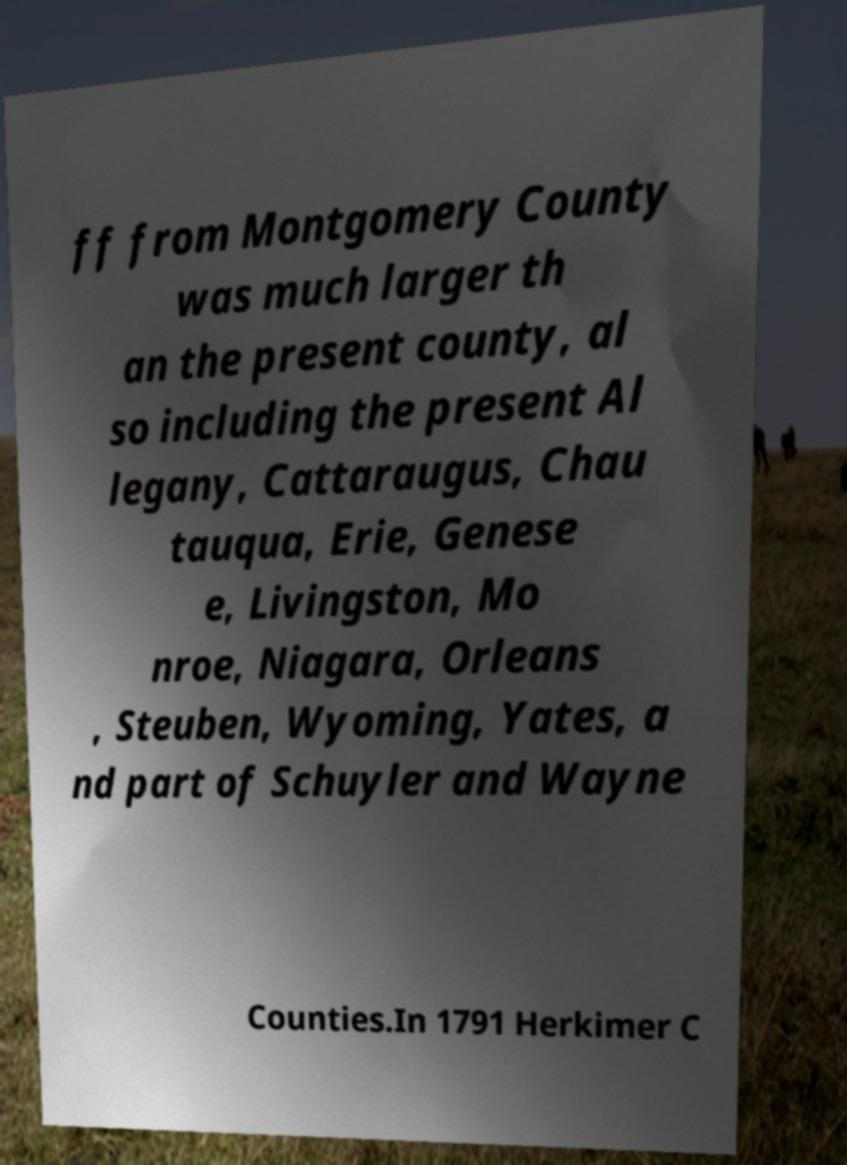Can you read and provide the text displayed in the image?This photo seems to have some interesting text. Can you extract and type it out for me? ff from Montgomery County was much larger th an the present county, al so including the present Al legany, Cattaraugus, Chau tauqua, Erie, Genese e, Livingston, Mo nroe, Niagara, Orleans , Steuben, Wyoming, Yates, a nd part of Schuyler and Wayne Counties.In 1791 Herkimer C 